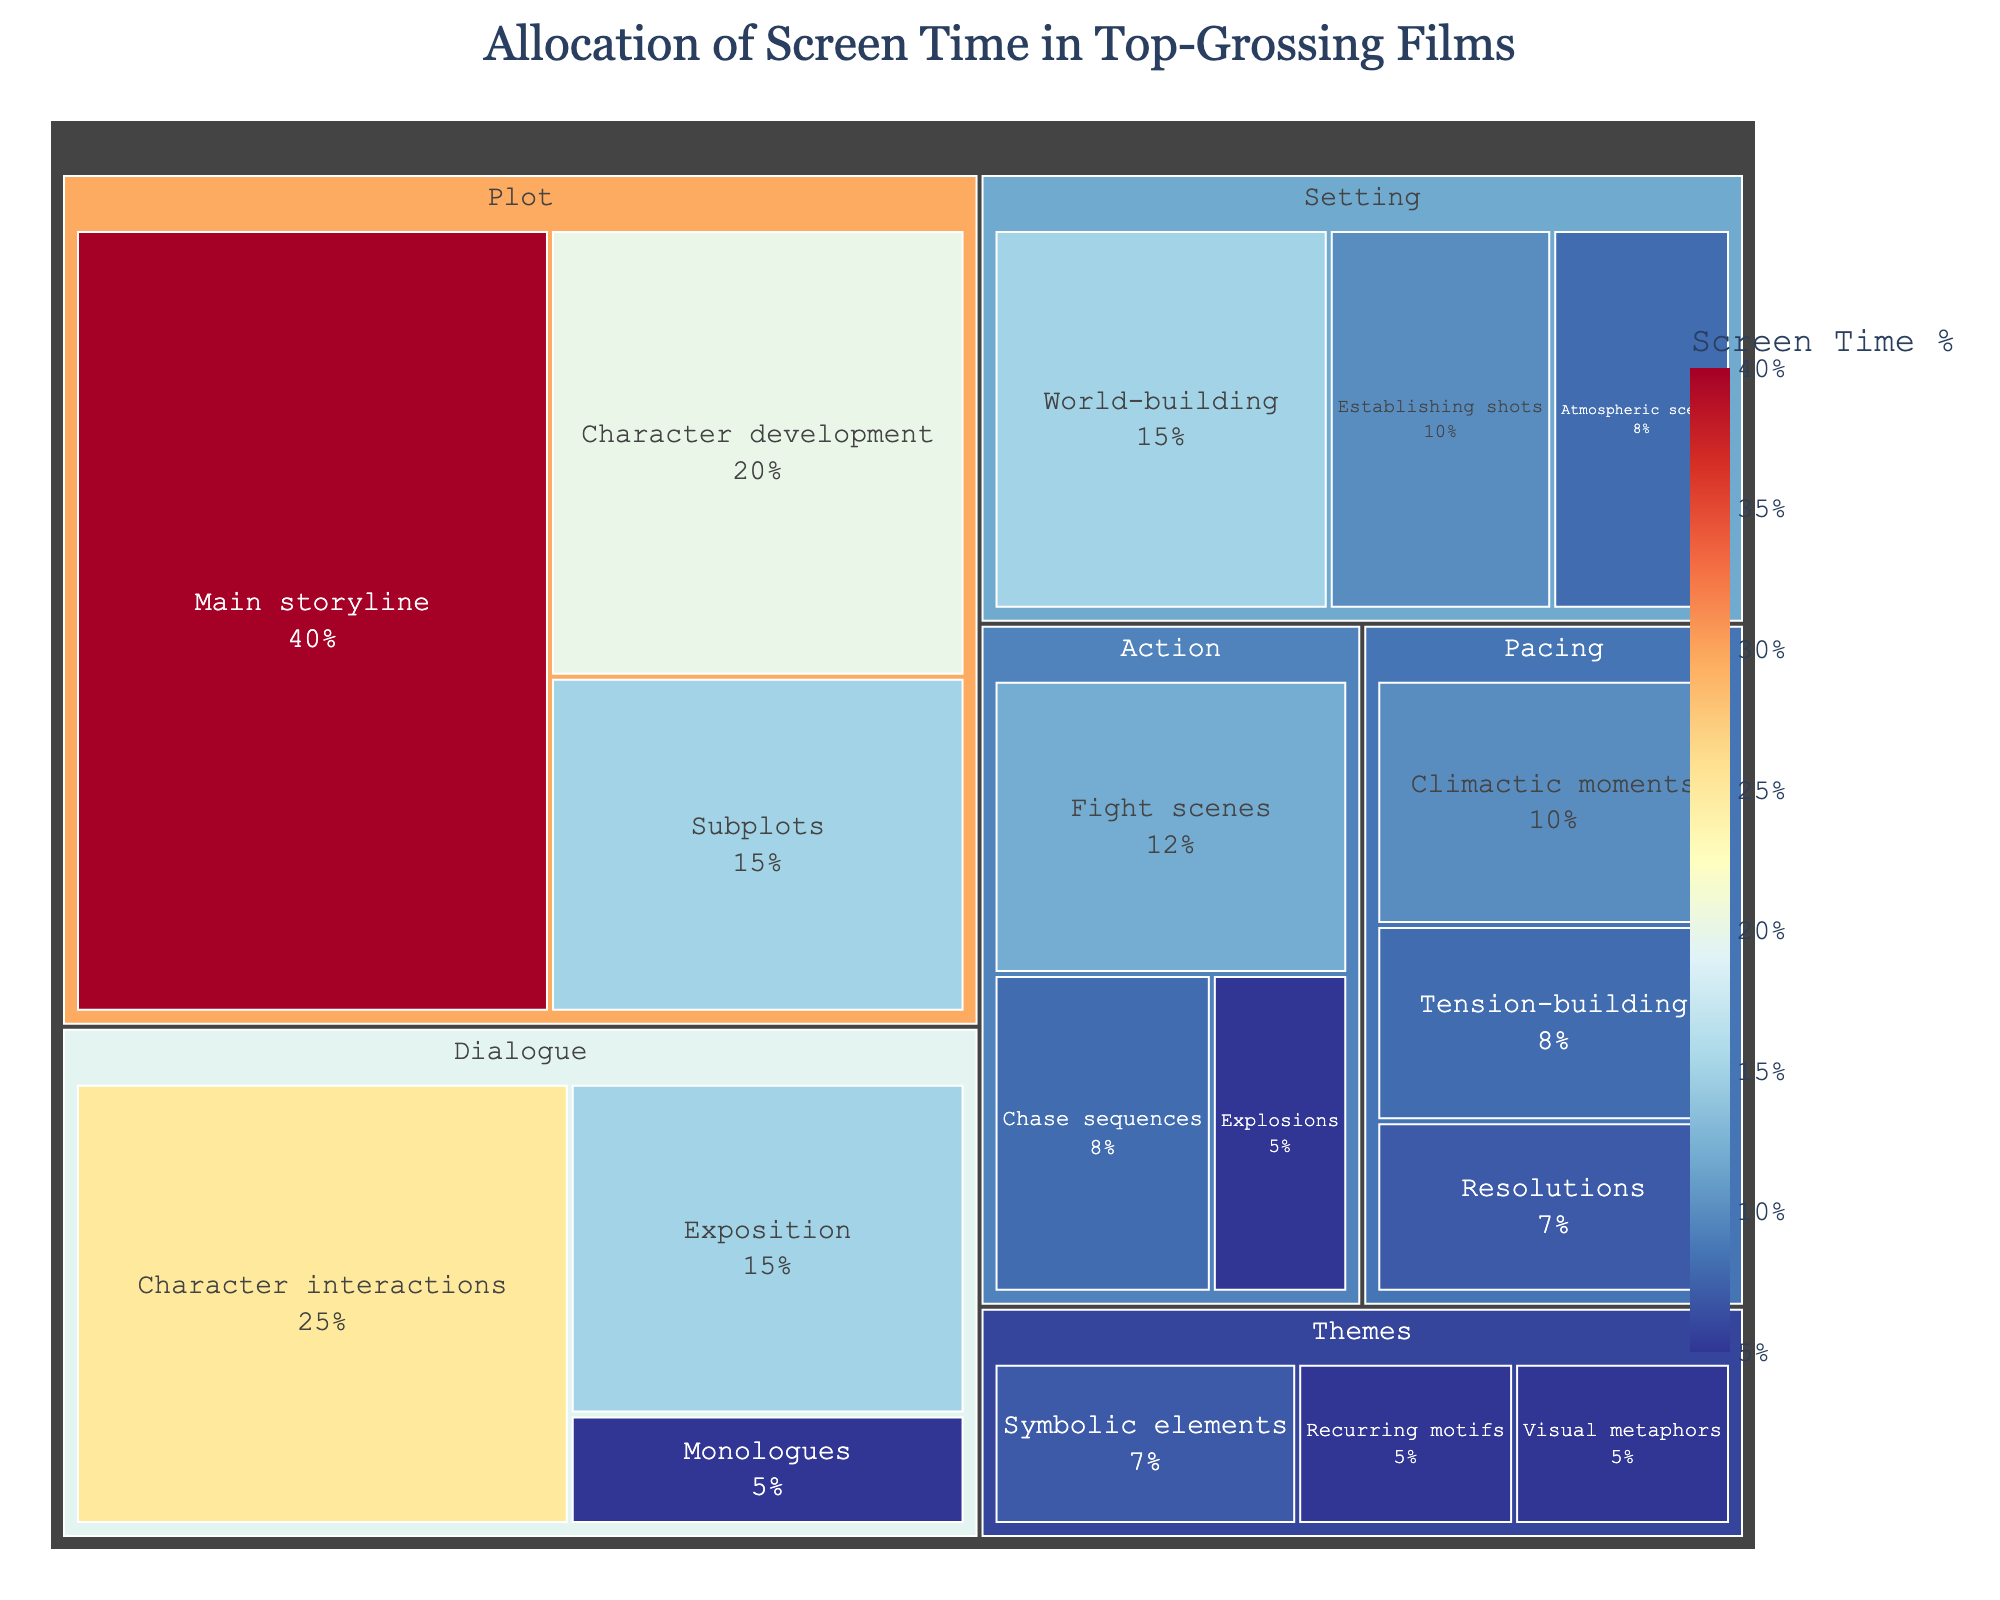What is the title of the treemap? The title is usually found at the top-center of the figure, and in this case, it provides a summary of the data visualized.
Answer: Allocation of Screen Time in Top-Grossing Films Which subcategory has the highest screen time allocation within the 'Plot' category? Within the 'Plot' category, the subcategory with the highest value represents the most screen time allocation. In this case, it is the 'Main storyline' with 40%.
Answer: Main storyline How much screen time is allocated to 'Character interactions' in the 'Dialogue' category? Look within the 'Dialogue' category and find the 'Character interactions' subcategory. It shows a value of 25%.
Answer: 25% What is the total screen time allocated to the 'Action' category? Add up the values of all subcategories within the Action category: Chase sequences (8) + Fight scenes (12) + Explosions (5).
Answer: 25% Which category allocates more screen time to 'Visual metaphors' or 'Recurring motifs' within the 'Themes' category? Compare the screen time of 'Visual metaphors' (5%) and 'Recurring motifs' (5%). Both have the same screen time allocation.
Answer: Equal What is the combined screen time percentage for 'Exposition' and 'Monologues' within the 'Dialogue' category? Add the screen time values for 'Exposition' (15) and 'Monologues' (5). Total = 15 + 5 = 20%.
Answer: 20% Which category has the smallest total allocation of screen time? Sum the values of each category and find the category with the smallest sum. For 'Themes' (5+7+5=17), 'Pacing' (10+8+7=25), 'Setting' (10+15+8=33), 'Dialogue' (15+25+5=45), 'Action' (8+12+5=25), 'Plot' (40+15+20=75). The Themes category has the smallest allocation of 17%.
Answer: Themes What is the difference in screen time allocation between 'Character development' in 'Plot' and 'Fight scenes' in 'Action'? Subtract the screen time of 'Fight scenes' (12) from 'Character development' (20). Difference = 20 - 12 = 8%.
Answer: 8% Which category uses more screen time for 'World-building' or 'Main storyline'? Compare the screen time for 'World-building' (15) and 'Main storyline' (40). 'Main storyline' has significantly more screen time.
Answer: Main storyline What is the average screen time allocation per subcategory in the 'Pacing' category? There are three subcategories in Pacing: Climactic moments (10), Tension-building (8), Resolutions (7). Sum them up (10 + 8 + 7 = 25), and divide by 3. Average = 25 / 3 ≈ 8.33%.
Answer: 8.33% 